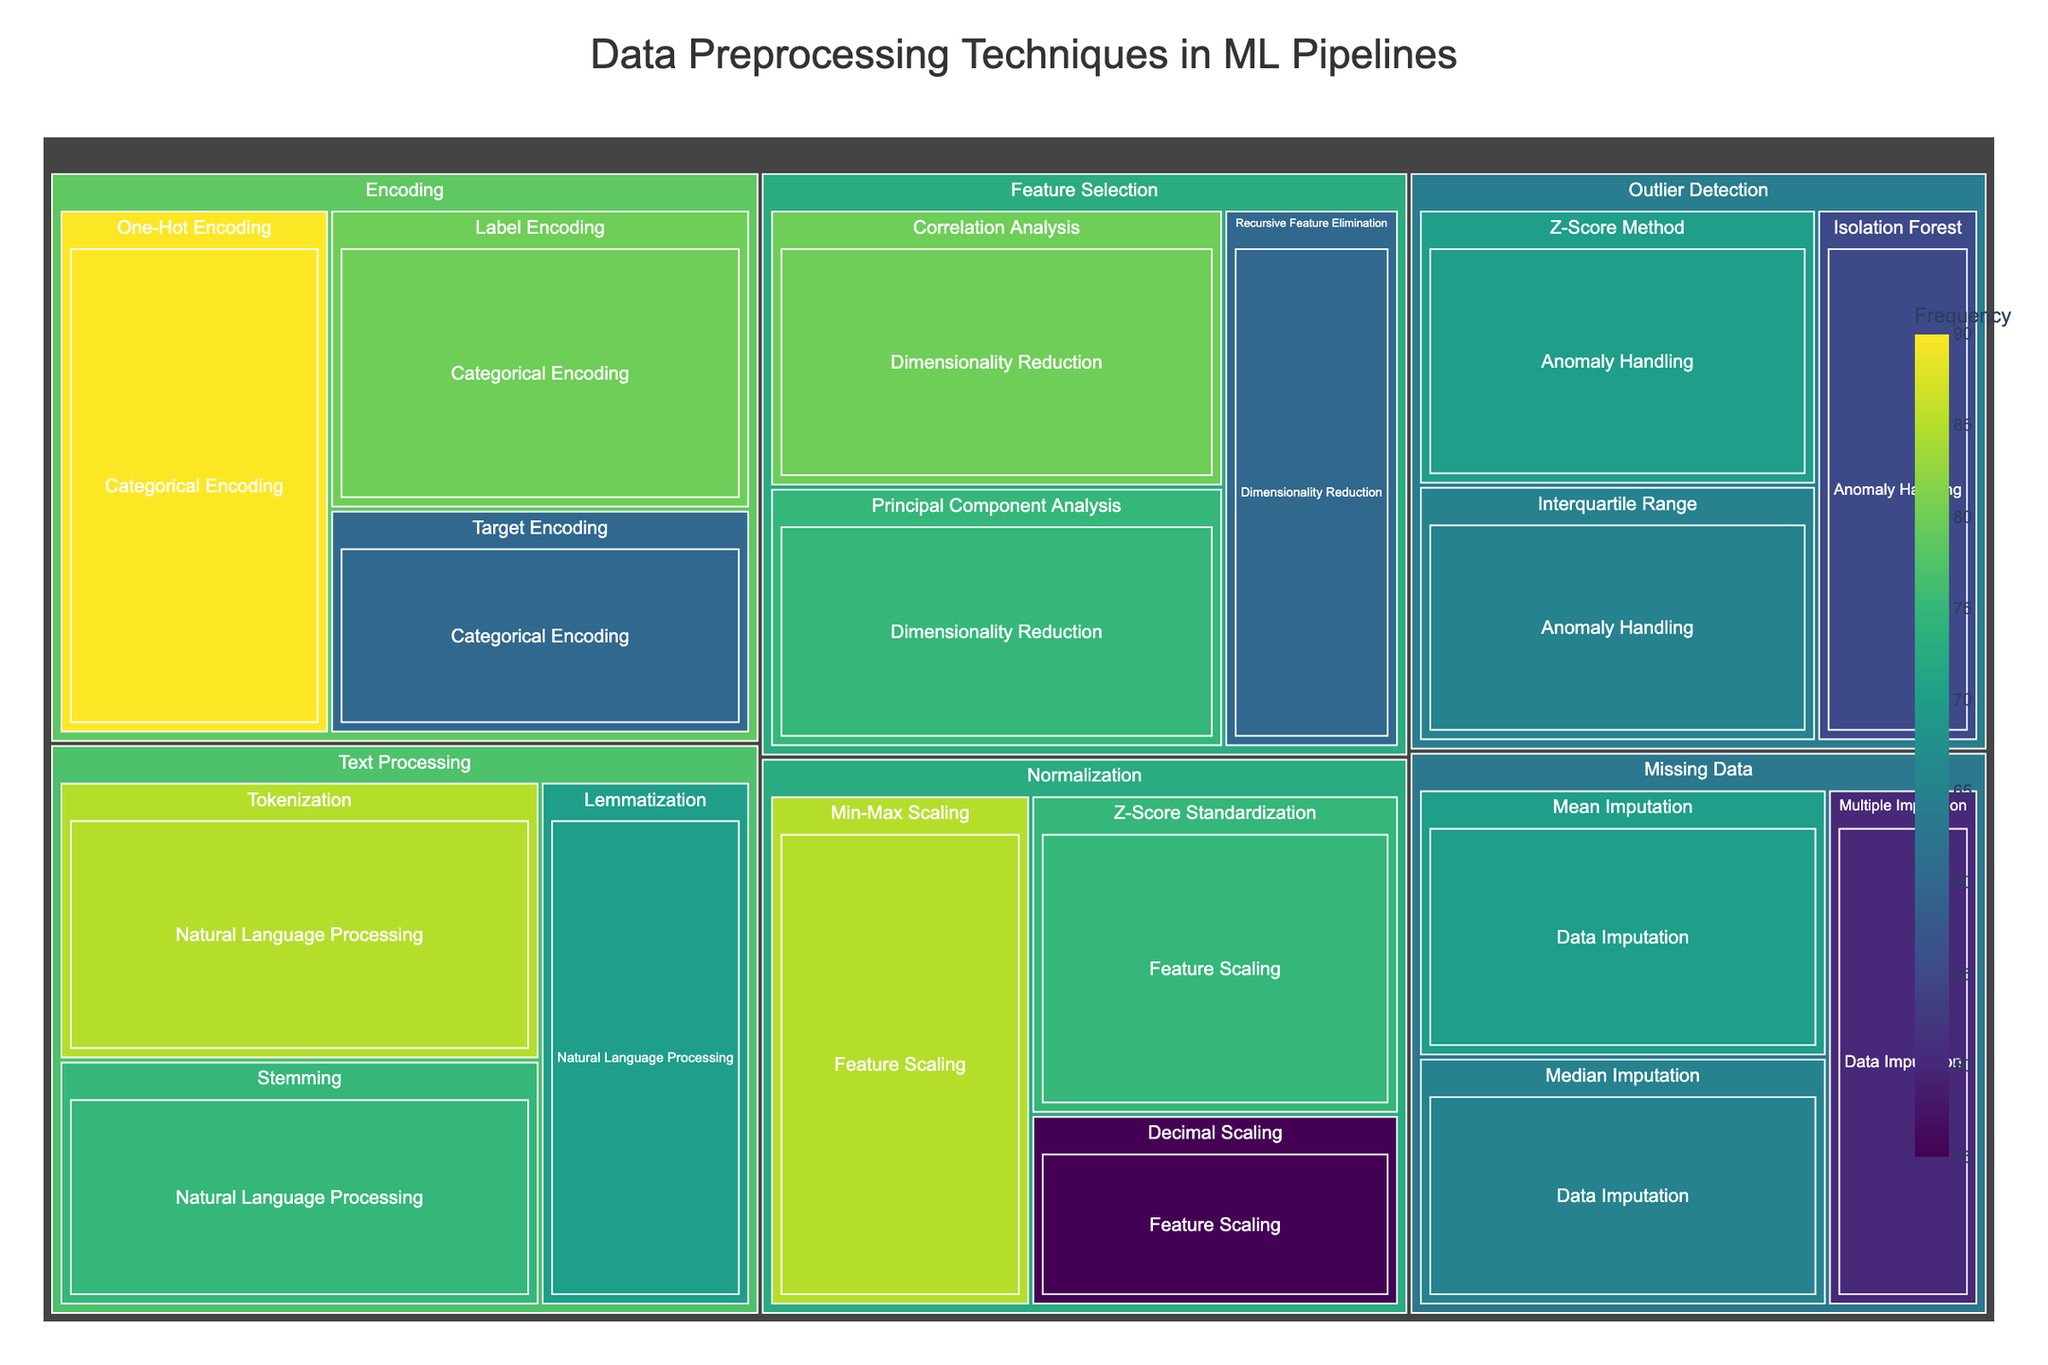What is the most frequently used data preprocessing technique? The most frequently used technique is displayed as the largest tile in the treemap with the highest frequency value.
Answer: One-Hot Encoding Which category contains the fewest techniques? To determine the category with the fewest techniques, find the category tiles and count the number of subcategory tiles within them.
Answer: Outlier Detection Compare the frequencies of Mean Imputation and Median Imputation. Which is more common? Locate the tiles for Mean Imputation and Median Imputation in the treemap and compare their frequency values.
Answer: Mean Imputation How does the frequency of Min-Max Scaling compare to Z-Score Standardization? Locate the tiles for Min-Max Scaling and Z-Score Standardization in the "Normalization" category to compare their frequencies.
Answer: Min-Max Scaling Which category has the highest total frequency value? Sum the frequencies of all techniques within each category and compare to find the highest total. Normalization has (85 + 75 + 45) = 205, Encoding has (90 + 80 + 60) = 230, Missing Data has (70 + 65 + 50) = 185, Feature Selection has (80 + 75 + 60) = 215, Outlier Detection has (70 + 65 + 55) = 190, Text Processing has (85 + 75 + 70) = 230.
Answer: Encoding; Text Processing What is the frequency range of Feature Scaling techniques within the Normalization category? Identify the techniques under "Normalization" for "Feature Scaling" and find their frequency values. The range is the difference between the highest and lowest values.
Answer: 85 to 45 Arrange the subcategories in the Encoding category by frequency in descending order. List the subcategories under "Encoding" and arrange them based on their frequency values, from highest to lowest.
Answer: One-Hot Encoding, Label Encoding, Target Encoding Is there a greater frequency for Categorical Encoding techniques or Natural Language Processing techniques? Add the frequencies of techniques under "Categorical Encoding" and "Natural Language Processing" subcategories and compare the sums. Categorical Encoding (90 + 80 + 60) = 230, Natural Language Processing (85 + 75 + 70) = 230.
Answer: Equal Which outlier detection technique is used the least? Identify the tiles under "Outlier Detection" and find the one with the lowest frequency value.
Answer: Isolation Forest What are the top three most common techniques used overall? Identify the tiles with the highest frequency values regardless of the category and list the top three.
Answer: One-Hot Encoding, Min-Max Scaling, Tokenization 